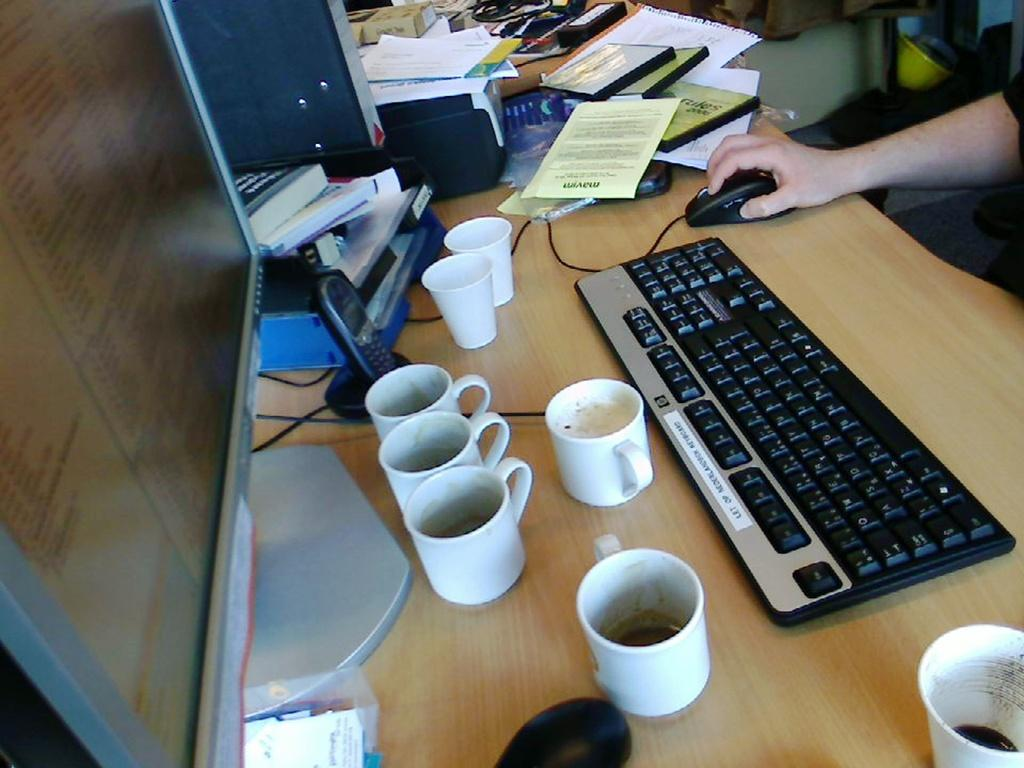What is the man in the image doing? The man is working on a computer. What is the man using to interact with the computer? There is a black keyboard and a mouse on the table. What type of table is in the image? There is a wooden table in the image. What else can be seen on the table besides the computer equipment? There are books, a disc, and six cups of tea on the table. How does the man use the brake while working on the computer in the image? There is no brake present in the image, as the man is working on a computer and not operating a vehicle. 